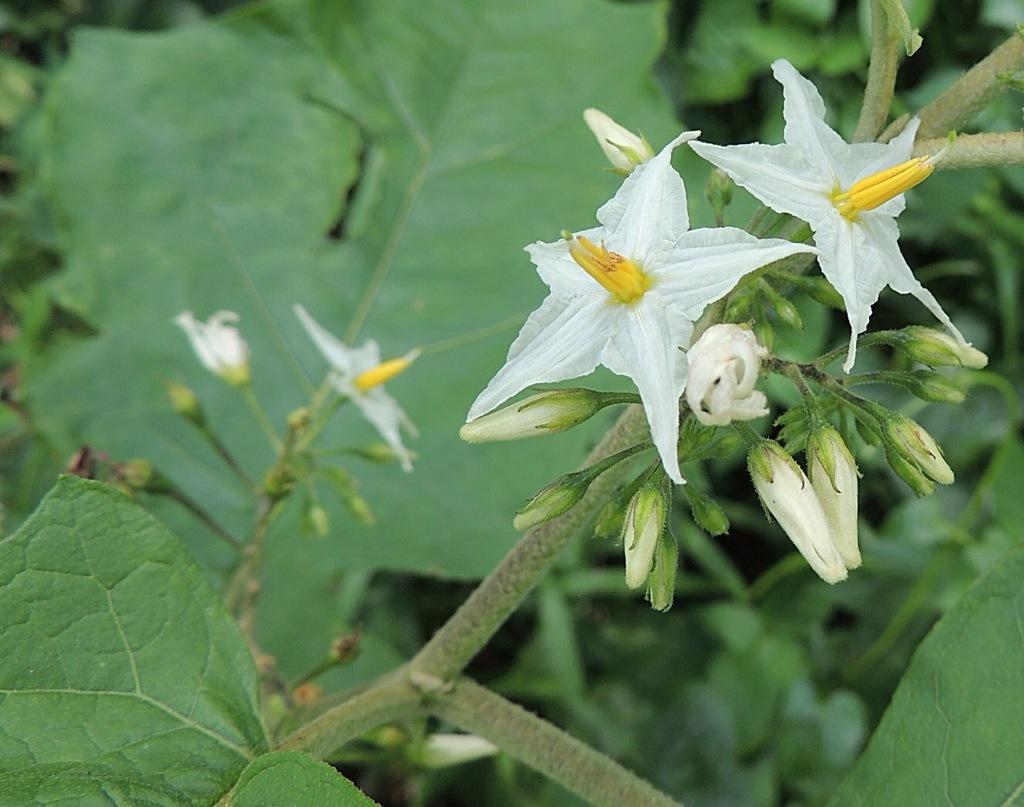What type of flowers are present in the image? There are white color flowers in the image. Can you describe the stage of growth for some of the flowers? Yes, there are buds in the image. What can be seen in the background of the image? In the background, leaves are visible on stems. How many pages are in the book that is being smashed by the flowers in the image? There is no book present in the image, and the flowers are not smashing anything. 